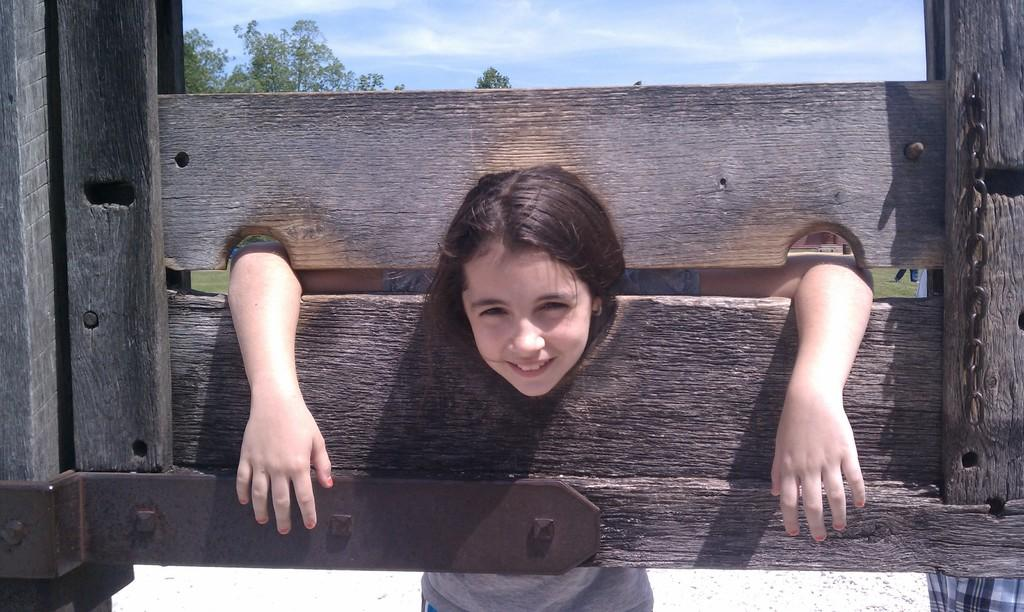What is the main object in the center of the image? There is a wooden board in the center of the image. What is the girl doing with the wooden board? The girl is putting her head on the wooden board. What can be seen in the background of the image? There are trees and the sky visible in the background of the image. What type of garden can be seen in the image? There is no garden present in the image. What scientific experiment is being conducted in the image? There is no scientific experiment depicted in the image. 